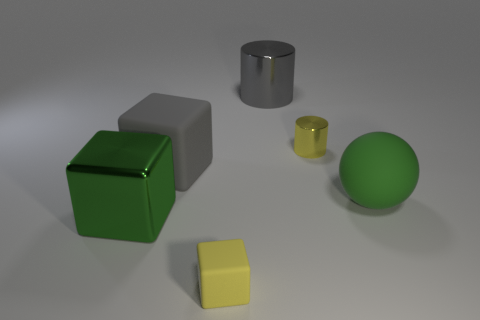Subtract all large blocks. How many blocks are left? 1 Add 1 big green metallic things. How many objects exist? 7 Subtract all cylinders. How many objects are left? 4 Add 6 big spheres. How many big spheres are left? 7 Add 6 big gray cylinders. How many big gray cylinders exist? 7 Subtract 0 red balls. How many objects are left? 6 Subtract all red cubes. Subtract all purple cylinders. How many cubes are left? 3 Subtract all large cyan metal spheres. Subtract all big cylinders. How many objects are left? 5 